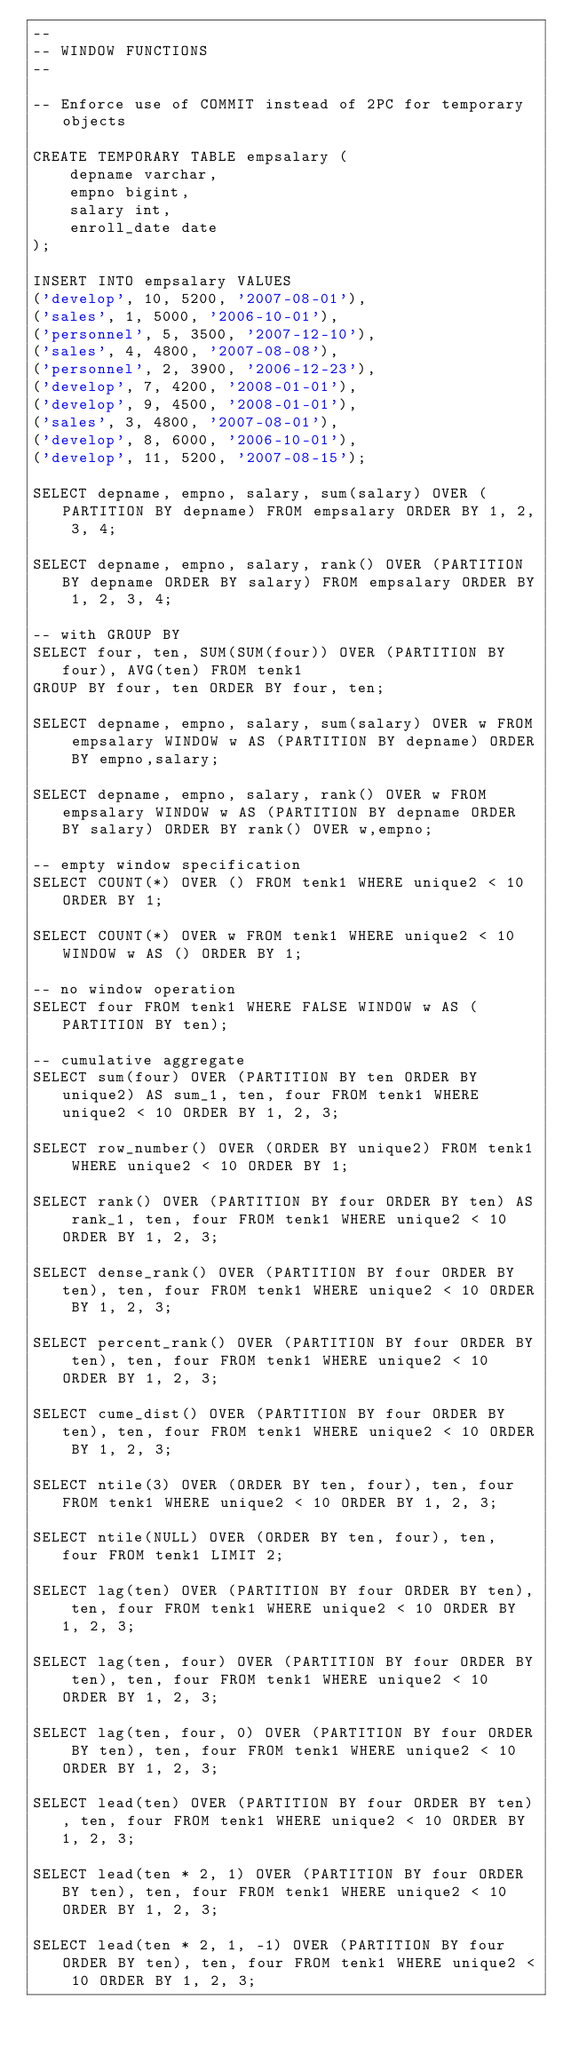<code> <loc_0><loc_0><loc_500><loc_500><_SQL_>--
-- WINDOW FUNCTIONS
--

-- Enforce use of COMMIT instead of 2PC for temporary objects

CREATE TEMPORARY TABLE empsalary (
    depname varchar,
    empno bigint,
    salary int,
    enroll_date date
);

INSERT INTO empsalary VALUES
('develop', 10, 5200, '2007-08-01'),
('sales', 1, 5000, '2006-10-01'),
('personnel', 5, 3500, '2007-12-10'),
('sales', 4, 4800, '2007-08-08'),
('personnel', 2, 3900, '2006-12-23'),
('develop', 7, 4200, '2008-01-01'),
('develop', 9, 4500, '2008-01-01'),
('sales', 3, 4800, '2007-08-01'),
('develop', 8, 6000, '2006-10-01'),
('develop', 11, 5200, '2007-08-15');

SELECT depname, empno, salary, sum(salary) OVER (PARTITION BY depname) FROM empsalary ORDER BY 1, 2, 3, 4;

SELECT depname, empno, salary, rank() OVER (PARTITION BY depname ORDER BY salary) FROM empsalary ORDER BY 1, 2, 3, 4;

-- with GROUP BY
SELECT four, ten, SUM(SUM(four)) OVER (PARTITION BY four), AVG(ten) FROM tenk1
GROUP BY four, ten ORDER BY four, ten;

SELECT depname, empno, salary, sum(salary) OVER w FROM empsalary WINDOW w AS (PARTITION BY depname) ORDER BY empno,salary;

SELECT depname, empno, salary, rank() OVER w FROM empsalary WINDOW w AS (PARTITION BY depname ORDER BY salary) ORDER BY rank() OVER w,empno;

-- empty window specification
SELECT COUNT(*) OVER () FROM tenk1 WHERE unique2 < 10 ORDER BY 1;

SELECT COUNT(*) OVER w FROM tenk1 WHERE unique2 < 10 WINDOW w AS () ORDER BY 1;

-- no window operation
SELECT four FROM tenk1 WHERE FALSE WINDOW w AS (PARTITION BY ten);

-- cumulative aggregate
SELECT sum(four) OVER (PARTITION BY ten ORDER BY unique2) AS sum_1, ten, four FROM tenk1 WHERE unique2 < 10 ORDER BY 1, 2, 3;

SELECT row_number() OVER (ORDER BY unique2) FROM tenk1 WHERE unique2 < 10 ORDER BY 1;

SELECT rank() OVER (PARTITION BY four ORDER BY ten) AS rank_1, ten, four FROM tenk1 WHERE unique2 < 10 ORDER BY 1, 2, 3;

SELECT dense_rank() OVER (PARTITION BY four ORDER BY ten), ten, four FROM tenk1 WHERE unique2 < 10 ORDER BY 1, 2, 3;

SELECT percent_rank() OVER (PARTITION BY four ORDER BY ten), ten, four FROM tenk1 WHERE unique2 < 10 ORDER BY 1, 2, 3;

SELECT cume_dist() OVER (PARTITION BY four ORDER BY ten), ten, four FROM tenk1 WHERE unique2 < 10 ORDER BY 1, 2, 3;

SELECT ntile(3) OVER (ORDER BY ten, four), ten, four FROM tenk1 WHERE unique2 < 10 ORDER BY 1, 2, 3;

SELECT ntile(NULL) OVER (ORDER BY ten, four), ten, four FROM tenk1 LIMIT 2;

SELECT lag(ten) OVER (PARTITION BY four ORDER BY ten), ten, four FROM tenk1 WHERE unique2 < 10 ORDER BY 1, 2, 3;

SELECT lag(ten, four) OVER (PARTITION BY four ORDER BY ten), ten, four FROM tenk1 WHERE unique2 < 10 ORDER BY 1, 2, 3;

SELECT lag(ten, four, 0) OVER (PARTITION BY four ORDER BY ten), ten, four FROM tenk1 WHERE unique2 < 10 ORDER BY 1, 2, 3;

SELECT lead(ten) OVER (PARTITION BY four ORDER BY ten), ten, four FROM tenk1 WHERE unique2 < 10 ORDER BY 1, 2, 3;

SELECT lead(ten * 2, 1) OVER (PARTITION BY four ORDER BY ten), ten, four FROM tenk1 WHERE unique2 < 10 ORDER BY 1, 2, 3;

SELECT lead(ten * 2, 1, -1) OVER (PARTITION BY four ORDER BY ten), ten, four FROM tenk1 WHERE unique2 < 10 ORDER BY 1, 2, 3;
</code> 